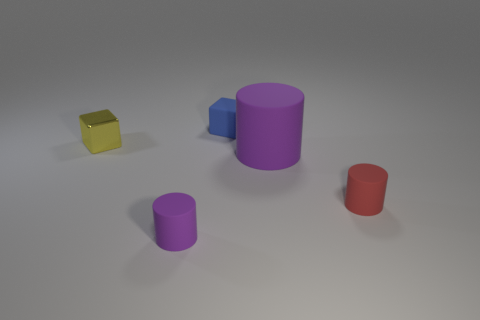How many purple things are large cubes or big cylinders?
Offer a very short reply. 1. Is the tiny blue thing that is behind the small metallic object made of the same material as the tiny yellow block?
Your response must be concise. No. What number of other things are there of the same material as the tiny blue cube
Your answer should be very brief. 3. What is the tiny blue block made of?
Provide a succinct answer. Rubber. There is a matte object to the left of the blue matte thing; what is its size?
Ensure brevity in your answer.  Small. What number of tiny cubes are on the left side of the tiny cylinder that is to the left of the red rubber thing?
Keep it short and to the point. 1. There is a purple rubber thing that is to the right of the tiny purple rubber thing; is its shape the same as the tiny thing in front of the small red matte object?
Give a very brief answer. Yes. What number of cubes are on the left side of the tiny blue matte object and on the right side of the metallic block?
Make the answer very short. 0. Is there another big thing of the same color as the big thing?
Ensure brevity in your answer.  No. There is a yellow metal thing that is the same size as the blue matte cube; what shape is it?
Ensure brevity in your answer.  Cube. 